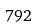<formula> <loc_0><loc_0><loc_500><loc_500>7 9 2</formula> 